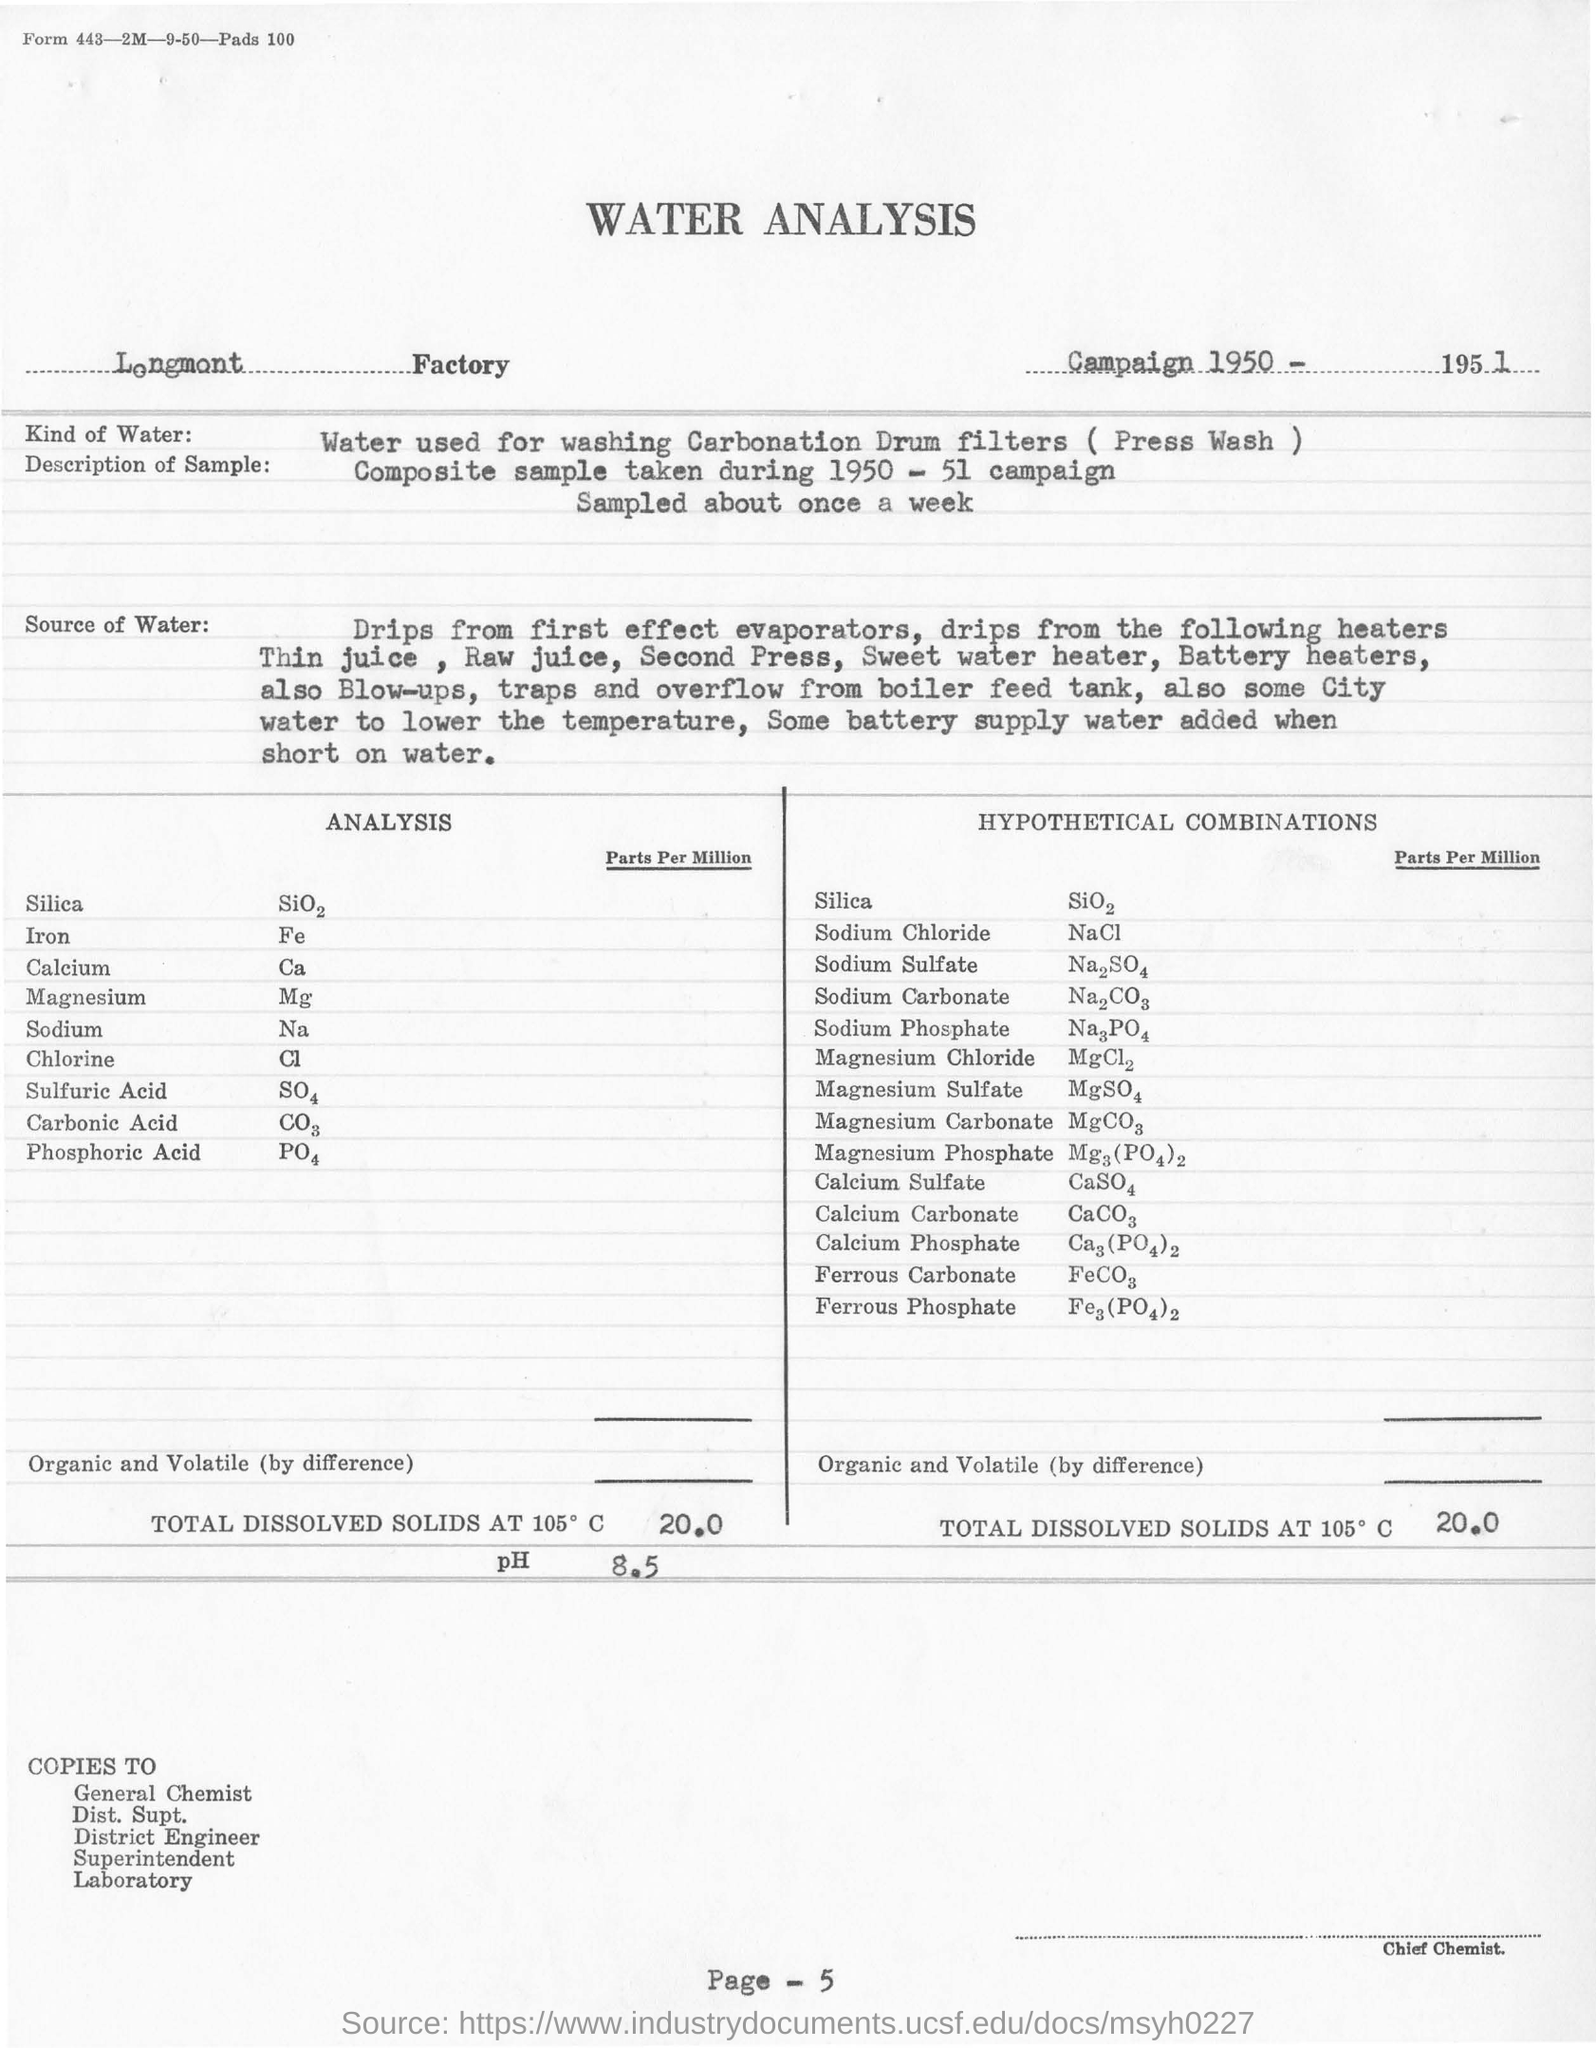Outline some significant characteristics in this image. The type of water used for analysis is Press Wash water from the Carbonation Drum filter. The page number mentioned in this document is 5. Longmont Factory is where the analysis was conducted. 